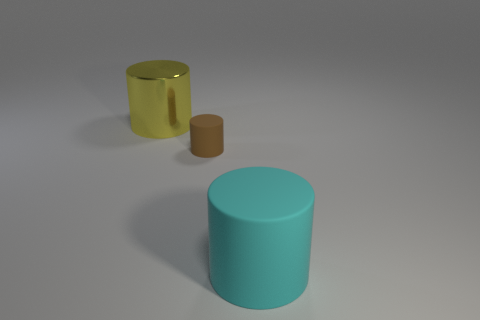There is a rubber object behind the cyan matte cylinder; how big is it?
Make the answer very short. Small. There is a big cyan thing that is made of the same material as the small cylinder; what shape is it?
Your answer should be very brief. Cylinder. Is there any other thing that has the same color as the big rubber cylinder?
Offer a terse response. No. There is a big cylinder that is behind the big cylinder that is in front of the yellow object; what is its color?
Your response must be concise. Yellow. What number of large objects are either cyan things or cylinders?
Ensure brevity in your answer.  2. What material is the small thing that is the same shape as the large yellow thing?
Offer a terse response. Rubber. Are there any other things that are the same material as the big yellow object?
Offer a terse response. No. The large matte cylinder has what color?
Your answer should be compact. Cyan. How many big cylinders are left of the matte cylinder that is right of the small brown cylinder?
Your answer should be very brief. 1. What is the material of the cylinder left of the small brown thing?
Provide a succinct answer. Metal. 